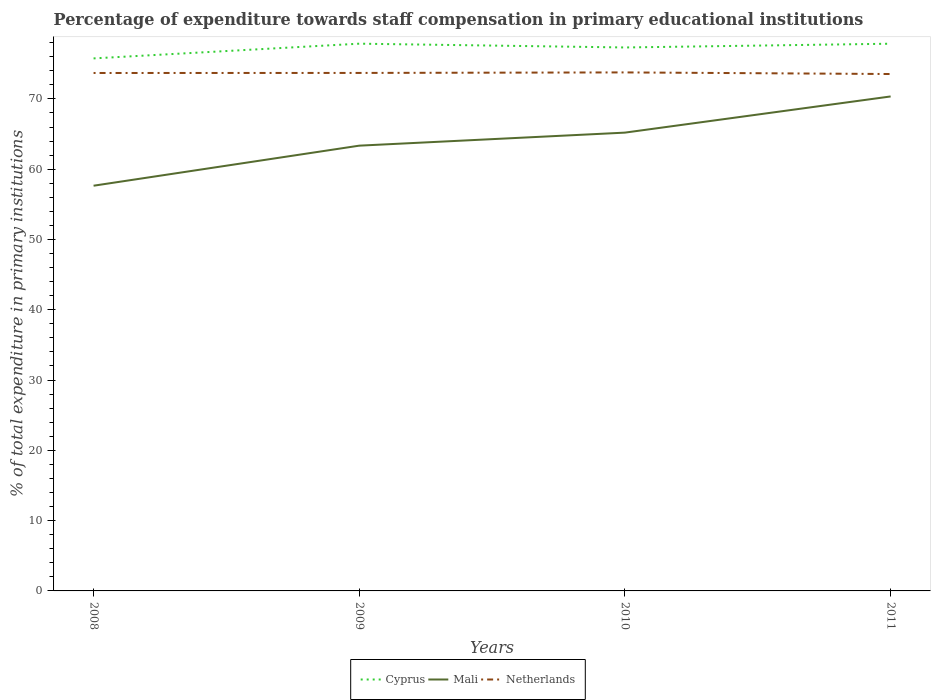Is the number of lines equal to the number of legend labels?
Make the answer very short. Yes. Across all years, what is the maximum percentage of expenditure towards staff compensation in Cyprus?
Your response must be concise. 75.76. What is the total percentage of expenditure towards staff compensation in Netherlands in the graph?
Make the answer very short. 0.15. What is the difference between the highest and the second highest percentage of expenditure towards staff compensation in Cyprus?
Offer a very short reply. 2.09. What is the difference between the highest and the lowest percentage of expenditure towards staff compensation in Netherlands?
Your answer should be compact. 3. Is the percentage of expenditure towards staff compensation in Cyprus strictly greater than the percentage of expenditure towards staff compensation in Netherlands over the years?
Ensure brevity in your answer.  No. How many years are there in the graph?
Ensure brevity in your answer.  4. Where does the legend appear in the graph?
Give a very brief answer. Bottom center. How many legend labels are there?
Your answer should be very brief. 3. What is the title of the graph?
Ensure brevity in your answer.  Percentage of expenditure towards staff compensation in primary educational institutions. What is the label or title of the X-axis?
Offer a terse response. Years. What is the label or title of the Y-axis?
Offer a very short reply. % of total expenditure in primary institutions. What is the % of total expenditure in primary institutions of Cyprus in 2008?
Provide a succinct answer. 75.76. What is the % of total expenditure in primary institutions in Mali in 2008?
Keep it short and to the point. 57.65. What is the % of total expenditure in primary institutions in Netherlands in 2008?
Provide a succinct answer. 73.68. What is the % of total expenditure in primary institutions in Cyprus in 2009?
Provide a succinct answer. 77.86. What is the % of total expenditure in primary institutions of Mali in 2009?
Your response must be concise. 63.35. What is the % of total expenditure in primary institutions in Netherlands in 2009?
Offer a terse response. 73.69. What is the % of total expenditure in primary institutions of Cyprus in 2010?
Offer a very short reply. 77.32. What is the % of total expenditure in primary institutions of Mali in 2010?
Provide a short and direct response. 65.2. What is the % of total expenditure in primary institutions in Netherlands in 2010?
Ensure brevity in your answer.  73.77. What is the % of total expenditure in primary institutions of Cyprus in 2011?
Ensure brevity in your answer.  77.85. What is the % of total expenditure in primary institutions of Mali in 2011?
Your answer should be very brief. 70.35. What is the % of total expenditure in primary institutions in Netherlands in 2011?
Provide a short and direct response. 73.54. Across all years, what is the maximum % of total expenditure in primary institutions in Cyprus?
Your response must be concise. 77.86. Across all years, what is the maximum % of total expenditure in primary institutions in Mali?
Keep it short and to the point. 70.35. Across all years, what is the maximum % of total expenditure in primary institutions of Netherlands?
Provide a short and direct response. 73.77. Across all years, what is the minimum % of total expenditure in primary institutions of Cyprus?
Offer a terse response. 75.76. Across all years, what is the minimum % of total expenditure in primary institutions in Mali?
Provide a short and direct response. 57.65. Across all years, what is the minimum % of total expenditure in primary institutions of Netherlands?
Provide a succinct answer. 73.54. What is the total % of total expenditure in primary institutions in Cyprus in the graph?
Ensure brevity in your answer.  308.78. What is the total % of total expenditure in primary institutions of Mali in the graph?
Offer a very short reply. 256.54. What is the total % of total expenditure in primary institutions of Netherlands in the graph?
Make the answer very short. 294.68. What is the difference between the % of total expenditure in primary institutions in Cyprus in 2008 and that in 2009?
Offer a very short reply. -2.09. What is the difference between the % of total expenditure in primary institutions in Mali in 2008 and that in 2009?
Ensure brevity in your answer.  -5.7. What is the difference between the % of total expenditure in primary institutions in Netherlands in 2008 and that in 2009?
Keep it short and to the point. -0.01. What is the difference between the % of total expenditure in primary institutions in Cyprus in 2008 and that in 2010?
Your response must be concise. -1.56. What is the difference between the % of total expenditure in primary institutions of Mali in 2008 and that in 2010?
Provide a succinct answer. -7.55. What is the difference between the % of total expenditure in primary institutions in Netherlands in 2008 and that in 2010?
Make the answer very short. -0.08. What is the difference between the % of total expenditure in primary institutions of Cyprus in 2008 and that in 2011?
Provide a succinct answer. -2.09. What is the difference between the % of total expenditure in primary institutions in Mali in 2008 and that in 2011?
Ensure brevity in your answer.  -12.7. What is the difference between the % of total expenditure in primary institutions of Netherlands in 2008 and that in 2011?
Offer a terse response. 0.15. What is the difference between the % of total expenditure in primary institutions in Cyprus in 2009 and that in 2010?
Make the answer very short. 0.54. What is the difference between the % of total expenditure in primary institutions of Mali in 2009 and that in 2010?
Your answer should be very brief. -1.85. What is the difference between the % of total expenditure in primary institutions in Netherlands in 2009 and that in 2010?
Your response must be concise. -0.07. What is the difference between the % of total expenditure in primary institutions in Cyprus in 2009 and that in 2011?
Keep it short and to the point. 0.01. What is the difference between the % of total expenditure in primary institutions in Mali in 2009 and that in 2011?
Offer a very short reply. -7. What is the difference between the % of total expenditure in primary institutions of Netherlands in 2009 and that in 2011?
Offer a very short reply. 0.16. What is the difference between the % of total expenditure in primary institutions of Cyprus in 2010 and that in 2011?
Ensure brevity in your answer.  -0.53. What is the difference between the % of total expenditure in primary institutions in Mali in 2010 and that in 2011?
Keep it short and to the point. -5.15. What is the difference between the % of total expenditure in primary institutions of Netherlands in 2010 and that in 2011?
Offer a terse response. 0.23. What is the difference between the % of total expenditure in primary institutions in Cyprus in 2008 and the % of total expenditure in primary institutions in Mali in 2009?
Your answer should be very brief. 12.41. What is the difference between the % of total expenditure in primary institutions of Cyprus in 2008 and the % of total expenditure in primary institutions of Netherlands in 2009?
Give a very brief answer. 2.07. What is the difference between the % of total expenditure in primary institutions of Mali in 2008 and the % of total expenditure in primary institutions of Netherlands in 2009?
Offer a very short reply. -16.04. What is the difference between the % of total expenditure in primary institutions in Cyprus in 2008 and the % of total expenditure in primary institutions in Mali in 2010?
Give a very brief answer. 10.56. What is the difference between the % of total expenditure in primary institutions in Cyprus in 2008 and the % of total expenditure in primary institutions in Netherlands in 2010?
Your response must be concise. 1.99. What is the difference between the % of total expenditure in primary institutions of Mali in 2008 and the % of total expenditure in primary institutions of Netherlands in 2010?
Offer a very short reply. -16.12. What is the difference between the % of total expenditure in primary institutions in Cyprus in 2008 and the % of total expenditure in primary institutions in Mali in 2011?
Provide a short and direct response. 5.41. What is the difference between the % of total expenditure in primary institutions in Cyprus in 2008 and the % of total expenditure in primary institutions in Netherlands in 2011?
Your answer should be very brief. 2.22. What is the difference between the % of total expenditure in primary institutions in Mali in 2008 and the % of total expenditure in primary institutions in Netherlands in 2011?
Provide a short and direct response. -15.89. What is the difference between the % of total expenditure in primary institutions of Cyprus in 2009 and the % of total expenditure in primary institutions of Mali in 2010?
Provide a short and direct response. 12.65. What is the difference between the % of total expenditure in primary institutions of Cyprus in 2009 and the % of total expenditure in primary institutions of Netherlands in 2010?
Offer a terse response. 4.09. What is the difference between the % of total expenditure in primary institutions of Mali in 2009 and the % of total expenditure in primary institutions of Netherlands in 2010?
Offer a very short reply. -10.42. What is the difference between the % of total expenditure in primary institutions of Cyprus in 2009 and the % of total expenditure in primary institutions of Mali in 2011?
Offer a very short reply. 7.51. What is the difference between the % of total expenditure in primary institutions of Cyprus in 2009 and the % of total expenditure in primary institutions of Netherlands in 2011?
Provide a succinct answer. 4.32. What is the difference between the % of total expenditure in primary institutions in Mali in 2009 and the % of total expenditure in primary institutions in Netherlands in 2011?
Your response must be concise. -10.19. What is the difference between the % of total expenditure in primary institutions in Cyprus in 2010 and the % of total expenditure in primary institutions in Mali in 2011?
Give a very brief answer. 6.97. What is the difference between the % of total expenditure in primary institutions of Cyprus in 2010 and the % of total expenditure in primary institutions of Netherlands in 2011?
Offer a terse response. 3.78. What is the difference between the % of total expenditure in primary institutions in Mali in 2010 and the % of total expenditure in primary institutions in Netherlands in 2011?
Ensure brevity in your answer.  -8.34. What is the average % of total expenditure in primary institutions in Cyprus per year?
Make the answer very short. 77.2. What is the average % of total expenditure in primary institutions of Mali per year?
Ensure brevity in your answer.  64.14. What is the average % of total expenditure in primary institutions of Netherlands per year?
Provide a succinct answer. 73.67. In the year 2008, what is the difference between the % of total expenditure in primary institutions in Cyprus and % of total expenditure in primary institutions in Mali?
Keep it short and to the point. 18.11. In the year 2008, what is the difference between the % of total expenditure in primary institutions of Cyprus and % of total expenditure in primary institutions of Netherlands?
Keep it short and to the point. 2.08. In the year 2008, what is the difference between the % of total expenditure in primary institutions of Mali and % of total expenditure in primary institutions of Netherlands?
Your answer should be very brief. -16.04. In the year 2009, what is the difference between the % of total expenditure in primary institutions in Cyprus and % of total expenditure in primary institutions in Mali?
Provide a succinct answer. 14.51. In the year 2009, what is the difference between the % of total expenditure in primary institutions in Cyprus and % of total expenditure in primary institutions in Netherlands?
Ensure brevity in your answer.  4.16. In the year 2009, what is the difference between the % of total expenditure in primary institutions in Mali and % of total expenditure in primary institutions in Netherlands?
Your answer should be very brief. -10.35. In the year 2010, what is the difference between the % of total expenditure in primary institutions in Cyprus and % of total expenditure in primary institutions in Mali?
Provide a succinct answer. 12.11. In the year 2010, what is the difference between the % of total expenditure in primary institutions of Cyprus and % of total expenditure in primary institutions of Netherlands?
Provide a short and direct response. 3.55. In the year 2010, what is the difference between the % of total expenditure in primary institutions in Mali and % of total expenditure in primary institutions in Netherlands?
Keep it short and to the point. -8.57. In the year 2011, what is the difference between the % of total expenditure in primary institutions in Cyprus and % of total expenditure in primary institutions in Mali?
Offer a terse response. 7.5. In the year 2011, what is the difference between the % of total expenditure in primary institutions of Cyprus and % of total expenditure in primary institutions of Netherlands?
Your answer should be very brief. 4.31. In the year 2011, what is the difference between the % of total expenditure in primary institutions in Mali and % of total expenditure in primary institutions in Netherlands?
Make the answer very short. -3.19. What is the ratio of the % of total expenditure in primary institutions of Cyprus in 2008 to that in 2009?
Make the answer very short. 0.97. What is the ratio of the % of total expenditure in primary institutions in Mali in 2008 to that in 2009?
Your answer should be compact. 0.91. What is the ratio of the % of total expenditure in primary institutions of Cyprus in 2008 to that in 2010?
Provide a succinct answer. 0.98. What is the ratio of the % of total expenditure in primary institutions in Mali in 2008 to that in 2010?
Give a very brief answer. 0.88. What is the ratio of the % of total expenditure in primary institutions of Netherlands in 2008 to that in 2010?
Your response must be concise. 1. What is the ratio of the % of total expenditure in primary institutions in Cyprus in 2008 to that in 2011?
Provide a short and direct response. 0.97. What is the ratio of the % of total expenditure in primary institutions of Mali in 2008 to that in 2011?
Your response must be concise. 0.82. What is the ratio of the % of total expenditure in primary institutions in Netherlands in 2008 to that in 2011?
Keep it short and to the point. 1. What is the ratio of the % of total expenditure in primary institutions in Mali in 2009 to that in 2010?
Offer a terse response. 0.97. What is the ratio of the % of total expenditure in primary institutions of Cyprus in 2009 to that in 2011?
Give a very brief answer. 1. What is the ratio of the % of total expenditure in primary institutions of Mali in 2009 to that in 2011?
Give a very brief answer. 0.9. What is the ratio of the % of total expenditure in primary institutions of Cyprus in 2010 to that in 2011?
Give a very brief answer. 0.99. What is the ratio of the % of total expenditure in primary institutions of Mali in 2010 to that in 2011?
Your answer should be very brief. 0.93. What is the difference between the highest and the second highest % of total expenditure in primary institutions of Cyprus?
Your answer should be compact. 0.01. What is the difference between the highest and the second highest % of total expenditure in primary institutions in Mali?
Your answer should be very brief. 5.15. What is the difference between the highest and the second highest % of total expenditure in primary institutions in Netherlands?
Provide a short and direct response. 0.07. What is the difference between the highest and the lowest % of total expenditure in primary institutions in Cyprus?
Provide a short and direct response. 2.09. What is the difference between the highest and the lowest % of total expenditure in primary institutions in Mali?
Your response must be concise. 12.7. What is the difference between the highest and the lowest % of total expenditure in primary institutions of Netherlands?
Your answer should be compact. 0.23. 